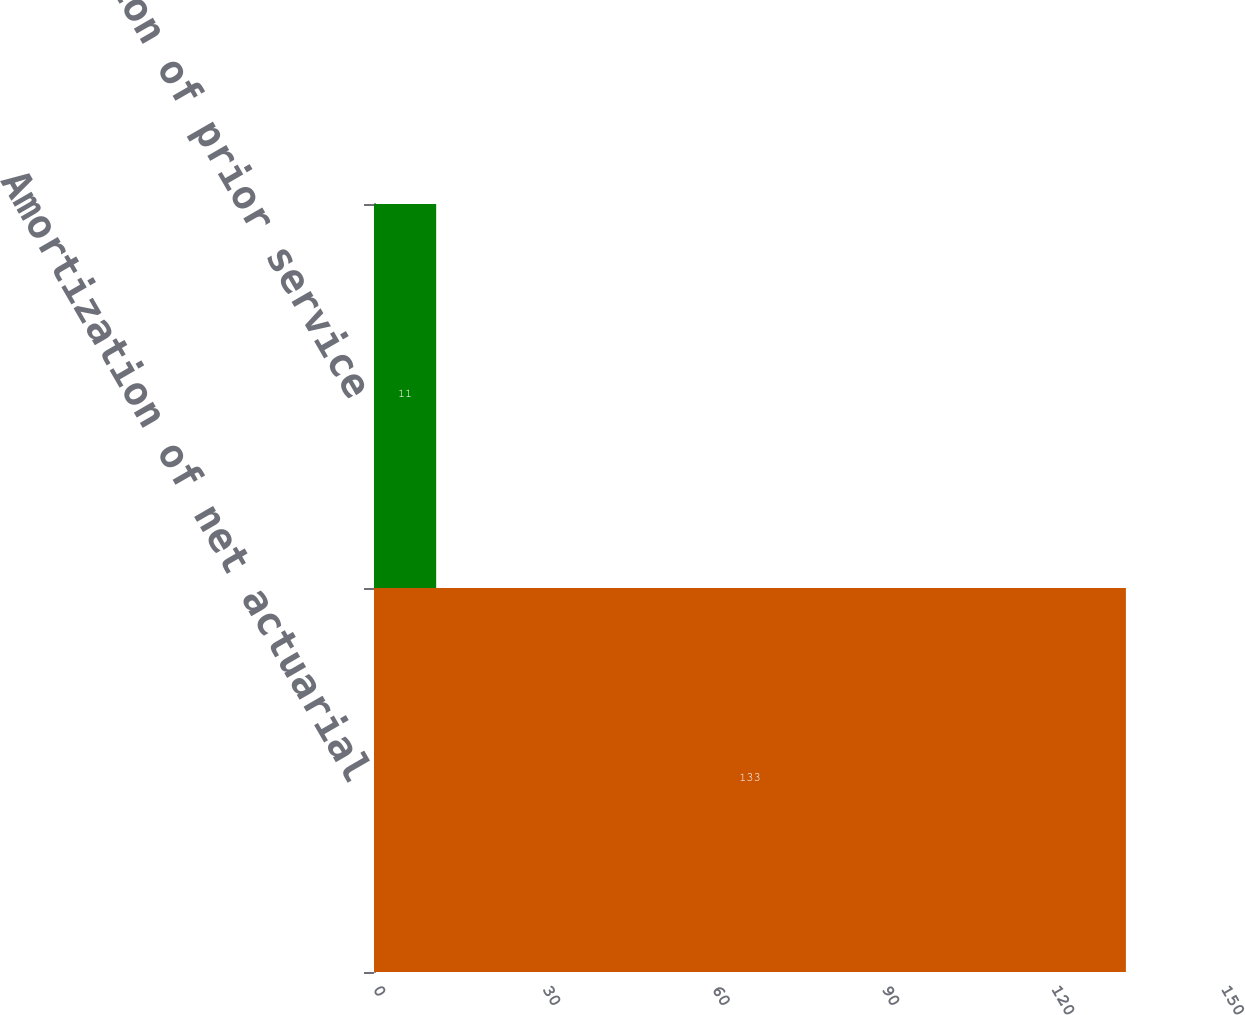Convert chart to OTSL. <chart><loc_0><loc_0><loc_500><loc_500><bar_chart><fcel>Amortization of net actuarial<fcel>Amortization of prior service<nl><fcel>133<fcel>11<nl></chart> 